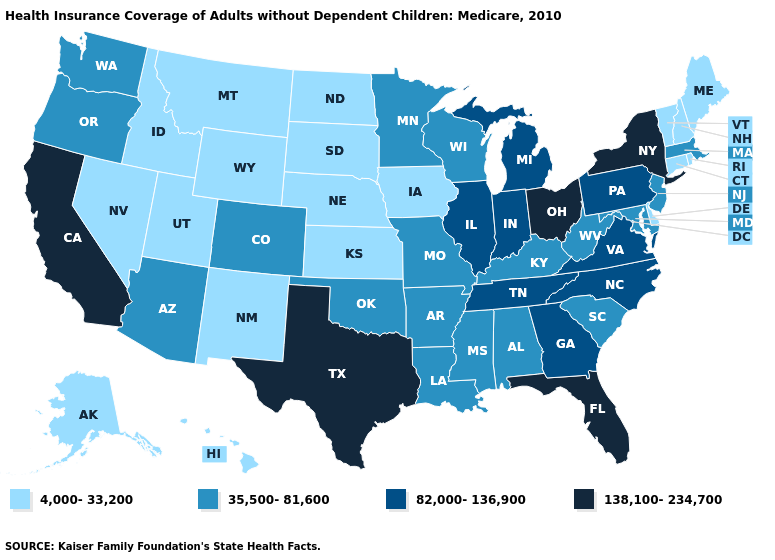What is the value of Arizona?
Short answer required. 35,500-81,600. Does the first symbol in the legend represent the smallest category?
Short answer required. Yes. Name the states that have a value in the range 4,000-33,200?
Answer briefly. Alaska, Connecticut, Delaware, Hawaii, Idaho, Iowa, Kansas, Maine, Montana, Nebraska, Nevada, New Hampshire, New Mexico, North Dakota, Rhode Island, South Dakota, Utah, Vermont, Wyoming. Name the states that have a value in the range 82,000-136,900?
Write a very short answer. Georgia, Illinois, Indiana, Michigan, North Carolina, Pennsylvania, Tennessee, Virginia. Name the states that have a value in the range 35,500-81,600?
Keep it brief. Alabama, Arizona, Arkansas, Colorado, Kentucky, Louisiana, Maryland, Massachusetts, Minnesota, Mississippi, Missouri, New Jersey, Oklahoma, Oregon, South Carolina, Washington, West Virginia, Wisconsin. What is the highest value in the USA?
Keep it brief. 138,100-234,700. Name the states that have a value in the range 138,100-234,700?
Quick response, please. California, Florida, New York, Ohio, Texas. Does Illinois have a lower value than Connecticut?
Give a very brief answer. No. What is the value of Indiana?
Short answer required. 82,000-136,900. Does Vermont have the lowest value in the USA?
Keep it brief. Yes. How many symbols are there in the legend?
Keep it brief. 4. Name the states that have a value in the range 4,000-33,200?
Give a very brief answer. Alaska, Connecticut, Delaware, Hawaii, Idaho, Iowa, Kansas, Maine, Montana, Nebraska, Nevada, New Hampshire, New Mexico, North Dakota, Rhode Island, South Dakota, Utah, Vermont, Wyoming. How many symbols are there in the legend?
Give a very brief answer. 4. Name the states that have a value in the range 82,000-136,900?
Short answer required. Georgia, Illinois, Indiana, Michigan, North Carolina, Pennsylvania, Tennessee, Virginia. Which states have the lowest value in the USA?
Give a very brief answer. Alaska, Connecticut, Delaware, Hawaii, Idaho, Iowa, Kansas, Maine, Montana, Nebraska, Nevada, New Hampshire, New Mexico, North Dakota, Rhode Island, South Dakota, Utah, Vermont, Wyoming. 